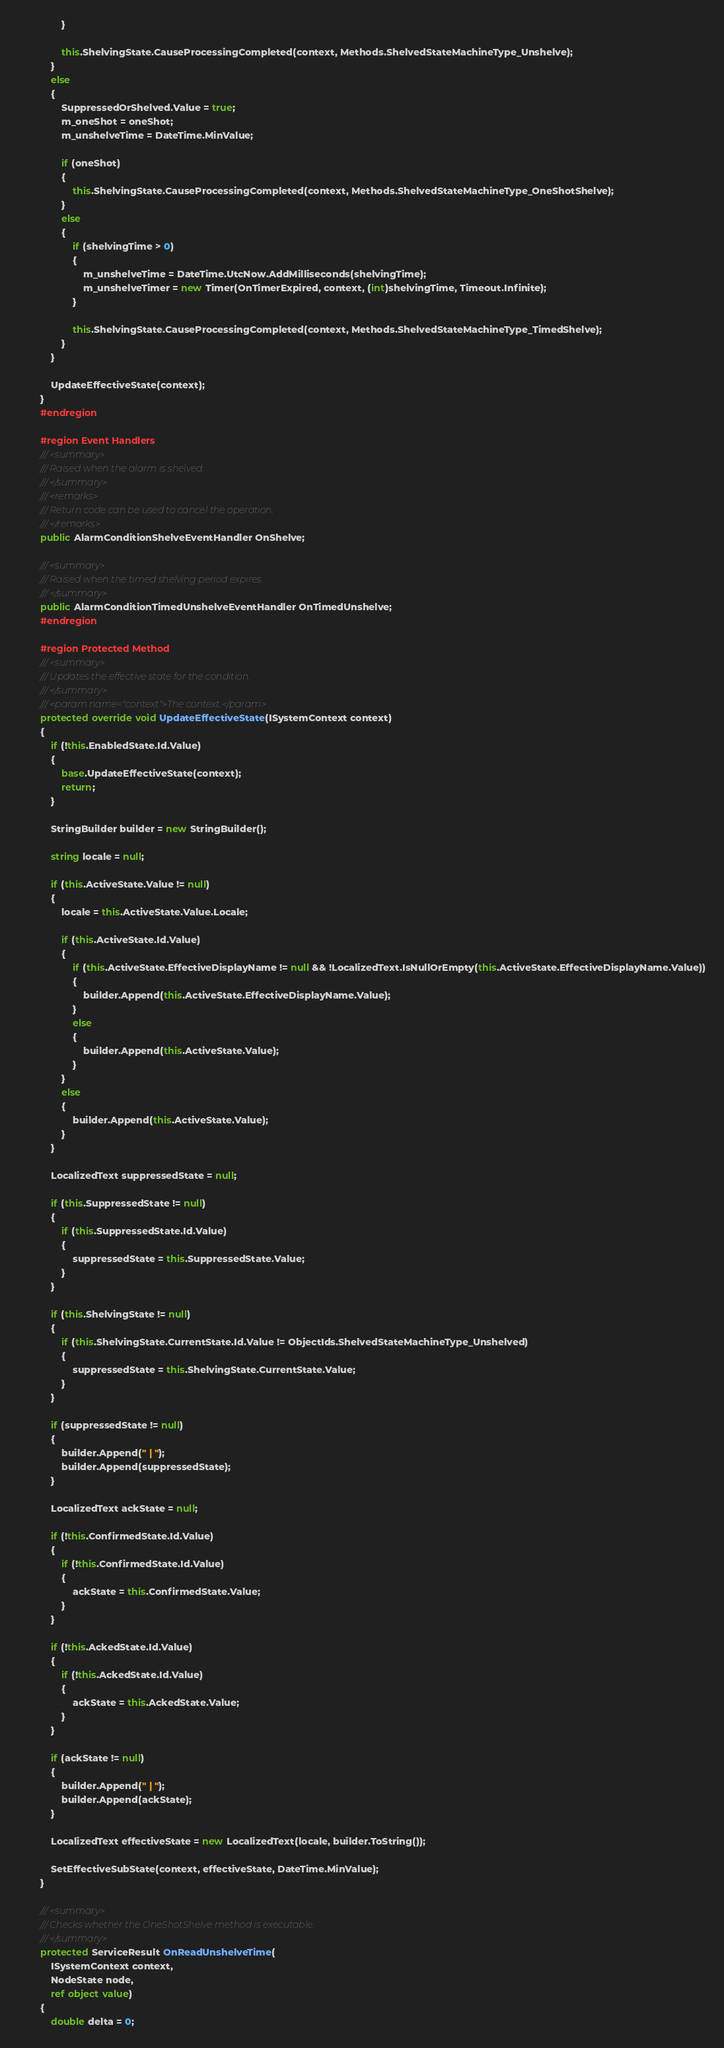Convert code to text. <code><loc_0><loc_0><loc_500><loc_500><_C#_>                }

                this.ShelvingState.CauseProcessingCompleted(context, Methods.ShelvedStateMachineType_Unshelve);
            }
            else
            {
                SuppressedOrShelved.Value = true;
                m_oneShot = oneShot;
                m_unshelveTime = DateTime.MinValue;

                if (oneShot)
                {
                    this.ShelvingState.CauseProcessingCompleted(context, Methods.ShelvedStateMachineType_OneShotShelve);
                }
                else
                {
                    if (shelvingTime > 0)
                    {
                        m_unshelveTime = DateTime.UtcNow.AddMilliseconds(shelvingTime);
                        m_unshelveTimer = new Timer(OnTimerExpired, context, (int)shelvingTime, Timeout.Infinite);
                    }

                    this.ShelvingState.CauseProcessingCompleted(context, Methods.ShelvedStateMachineType_TimedShelve);
                }
            }

            UpdateEffectiveState(context);
        }
        #endregion

        #region Event Handlers
        /// <summary>
        /// Raised when the alarm is shelved.
        /// </summary>
        /// <remarks>
        /// Return code can be used to cancel the operation.
        /// </remarks>
        public AlarmConditionShelveEventHandler OnShelve;

        /// <summary>
        /// Raised when the timed shelving period expires.
        /// </summary>
        public AlarmConditionTimedUnshelveEventHandler OnTimedUnshelve;
        #endregion

        #region Protected Method
        /// <summary>
        /// Updates the effective state for the condition.
        /// </summary>
        /// <param name="context">The context.</param>
        protected override void UpdateEffectiveState(ISystemContext context)
        {
            if (!this.EnabledState.Id.Value)
            {
                base.UpdateEffectiveState(context);
                return;
            }

            StringBuilder builder = new StringBuilder();

            string locale = null;

            if (this.ActiveState.Value != null)
            {
                locale = this.ActiveState.Value.Locale;

                if (this.ActiveState.Id.Value)
                {
                    if (this.ActiveState.EffectiveDisplayName != null && !LocalizedText.IsNullOrEmpty(this.ActiveState.EffectiveDisplayName.Value))
                    {
                        builder.Append(this.ActiveState.EffectiveDisplayName.Value);
                    }
                    else
                    {
                        builder.Append(this.ActiveState.Value);
                    }
                }
                else
                {
                    builder.Append(this.ActiveState.Value);
                }
            }

            LocalizedText suppressedState = null;

            if (this.SuppressedState != null)
            {
                if (this.SuppressedState.Id.Value)
                {
                    suppressedState = this.SuppressedState.Value;
                }
            }

            if (this.ShelvingState != null)
            {
                if (this.ShelvingState.CurrentState.Id.Value != ObjectIds.ShelvedStateMachineType_Unshelved)
                {
                    suppressedState = this.ShelvingState.CurrentState.Value;
                }
            }

            if (suppressedState != null)
            {
                builder.Append(" | ");
                builder.Append(suppressedState);
            }

            LocalizedText ackState = null;

            if (!this.ConfirmedState.Id.Value)
            {
                if (!this.ConfirmedState.Id.Value)
                {
                    ackState = this.ConfirmedState.Value;
                }
            }

            if (!this.AckedState.Id.Value)
            {
                if (!this.AckedState.Id.Value)
                {
                    ackState = this.AckedState.Value;
                }
            }

            if (ackState != null)
            {
                builder.Append(" | ");
                builder.Append(ackState);
            }

            LocalizedText effectiveState = new LocalizedText(locale, builder.ToString());

            SetEffectiveSubState(context, effectiveState, DateTime.MinValue);
        }

        /// <summary>
        /// Checks whether the OneShotShelve method is executable.
        /// </summary>
        protected ServiceResult OnReadUnshelveTime(
            ISystemContext context,
            NodeState node,
            ref object value)
        {
            double delta = 0;
</code> 